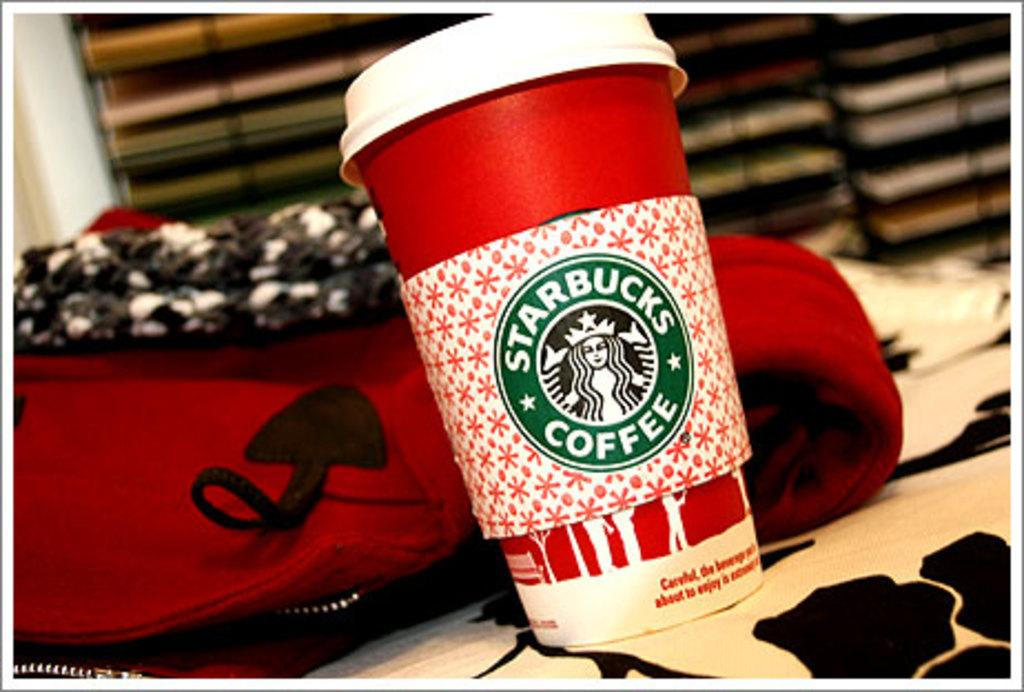What is present in the image? There is a cup in the image. What is written on the cup? The cup has "Starbucks Coffee" written on it. What type of umbrella is being used to stir the coffee in the cup? There is no umbrella present in the image, and therefore no such stirring tool can be observed. What shape is the coffee in the cup? The image does not provide enough detail to determine the shape of the coffee in the cup. 